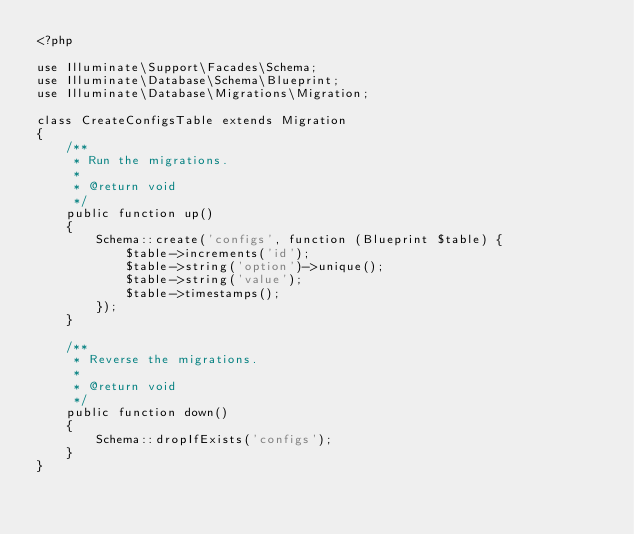<code> <loc_0><loc_0><loc_500><loc_500><_PHP_><?php

use Illuminate\Support\Facades\Schema;
use Illuminate\Database\Schema\Blueprint;
use Illuminate\Database\Migrations\Migration;

class CreateConfigsTable extends Migration
{
    /**
     * Run the migrations.
     *
     * @return void
     */
    public function up()
    {
        Schema::create('configs', function (Blueprint $table) {
            $table->increments('id');
            $table->string('option')->unique();
            $table->string('value');
            $table->timestamps();
        });
    }

    /**
     * Reverse the migrations.
     *
     * @return void
     */
    public function down()
    {
        Schema::dropIfExists('configs');
    }
}
</code> 